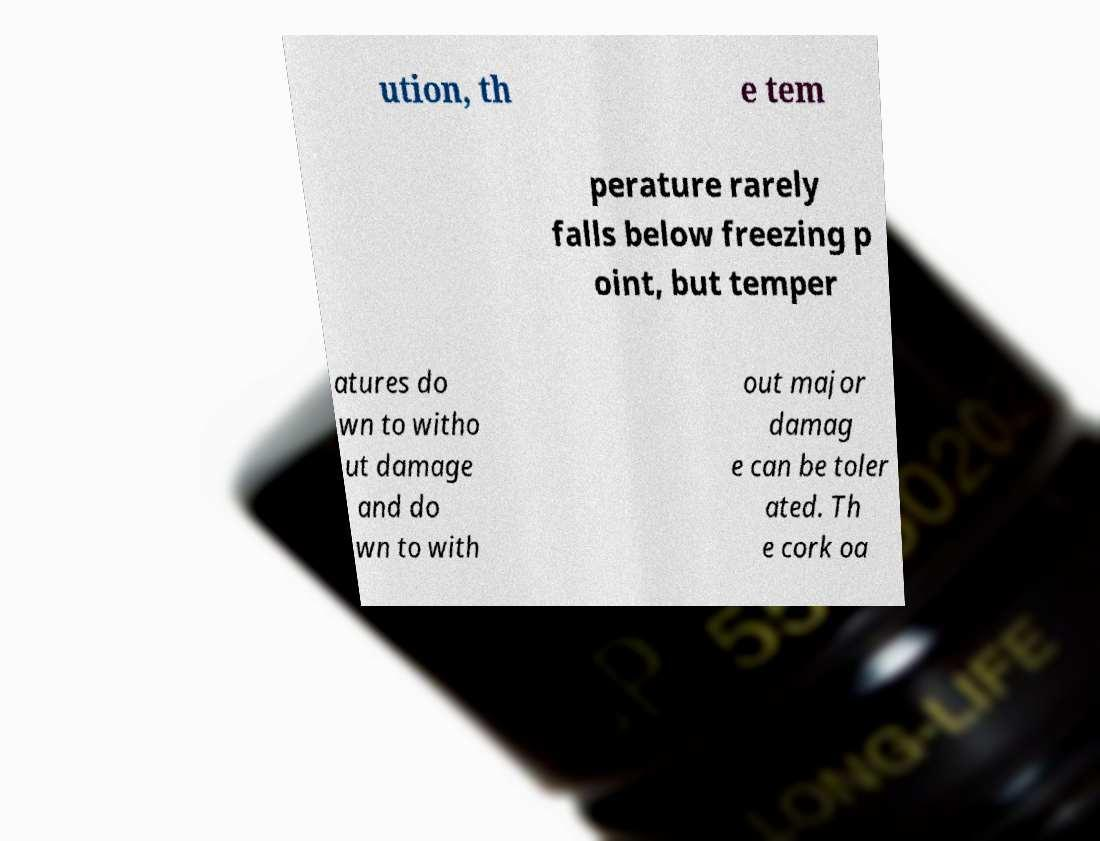Could you assist in decoding the text presented in this image and type it out clearly? ution, th e tem perature rarely falls below freezing p oint, but temper atures do wn to witho ut damage and do wn to with out major damag e can be toler ated. Th e cork oa 